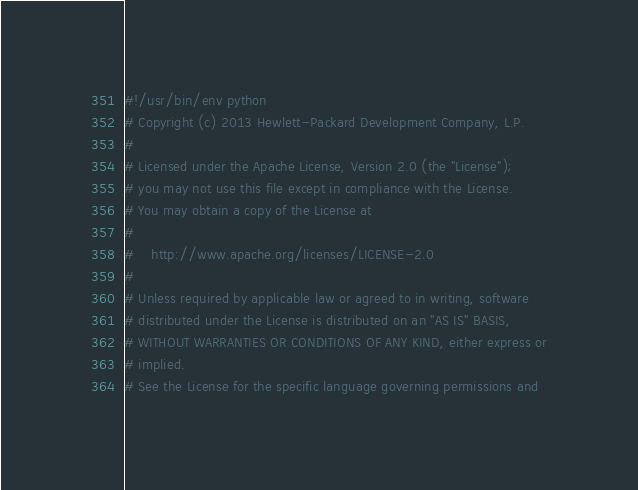<code> <loc_0><loc_0><loc_500><loc_500><_Python_>#!/usr/bin/env python
# Copyright (c) 2013 Hewlett-Packard Development Company, L.P.
#
# Licensed under the Apache License, Version 2.0 (the "License");
# you may not use this file except in compliance with the License.
# You may obtain a copy of the License at
#
#    http://www.apache.org/licenses/LICENSE-2.0
#
# Unless required by applicable law or agreed to in writing, software
# distributed under the License is distributed on an "AS IS" BASIS,
# WITHOUT WARRANTIES OR CONDITIONS OF ANY KIND, either express or
# implied.
# See the License for the specific language governing permissions and</code> 